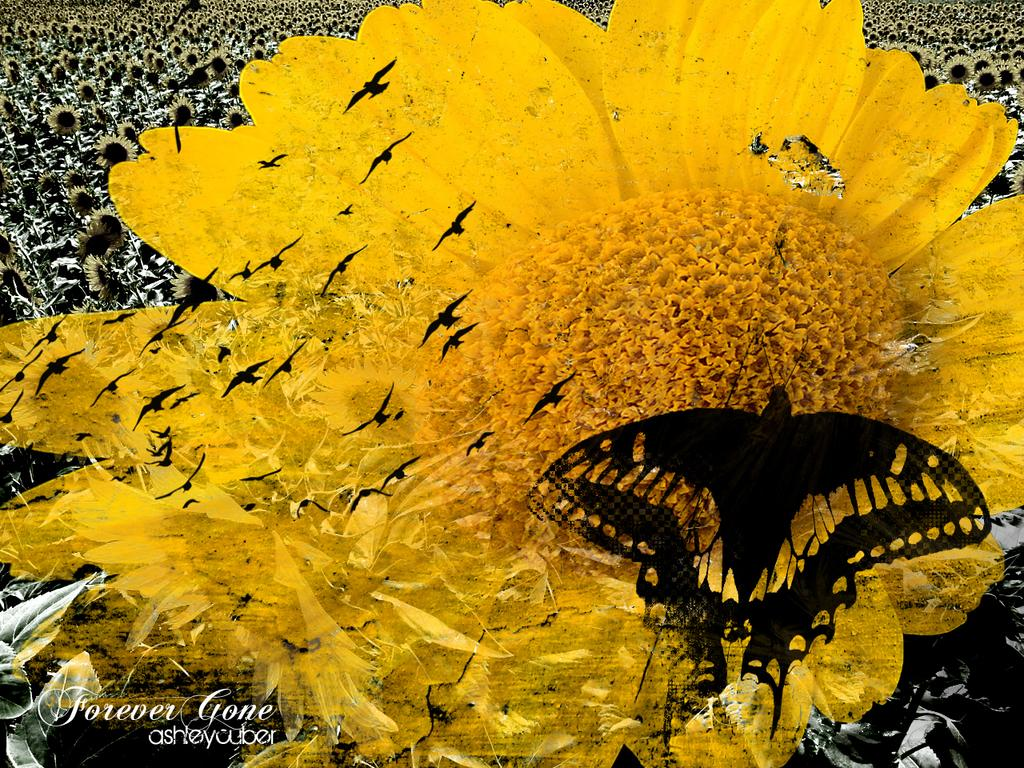What type of living organisms can be seen in the image? There are flowers, birds, and a butterfly in the image. What is the primary subject of the image? The primary subject of the image is the flowers. Are there any other elements in the image besides the living organisms? Yes, the image has a watermark. How many hours of sleep do the flowers require in the image? Flowers do not require sleep, as they are not living organisms with the ability to sleep. 